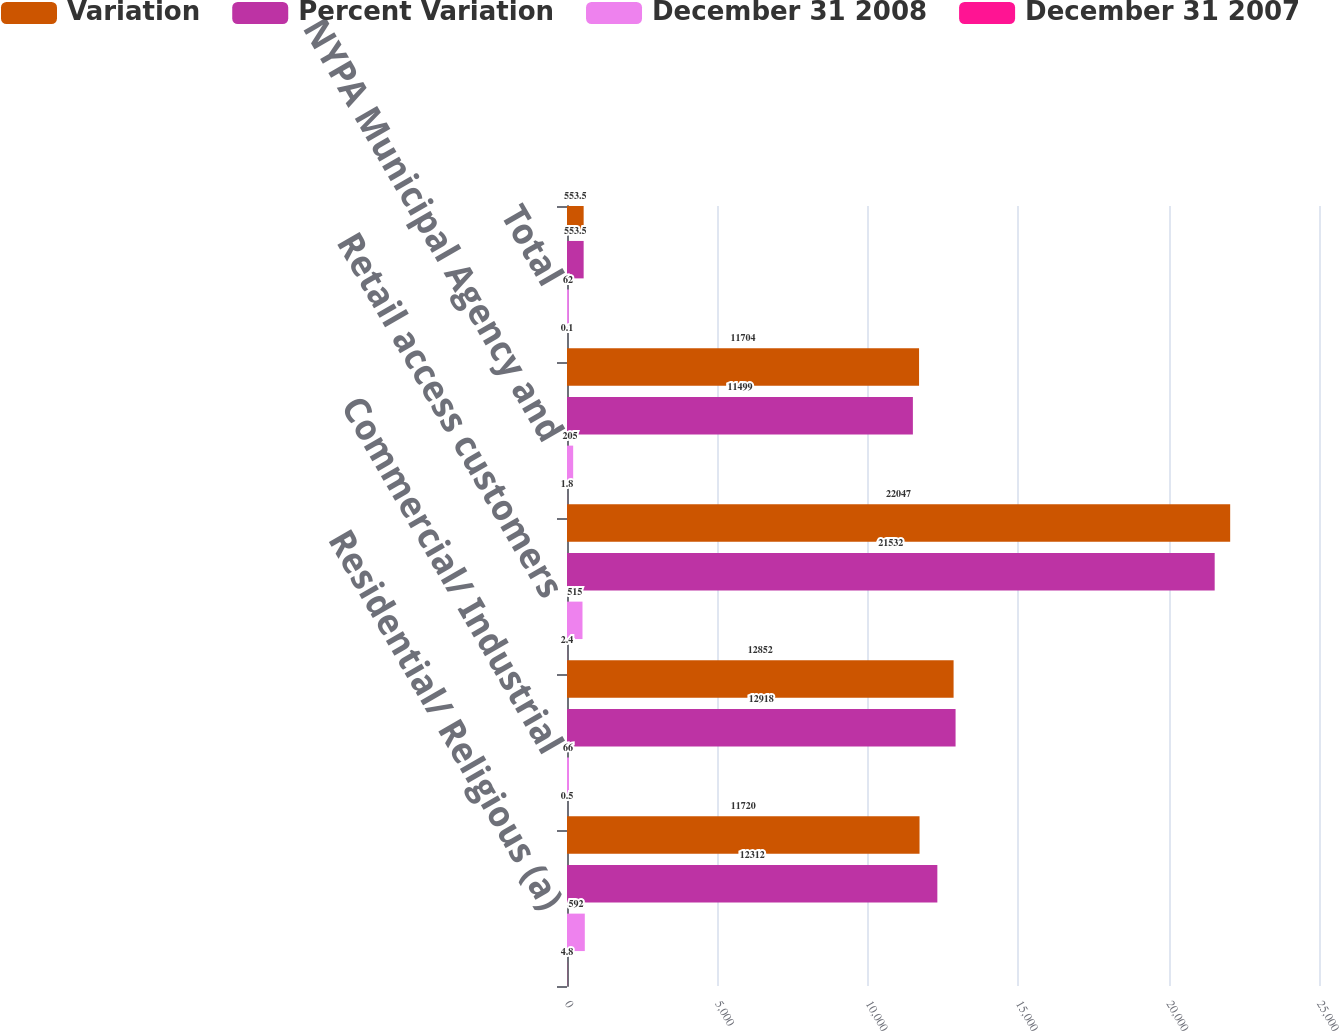Convert chart to OTSL. <chart><loc_0><loc_0><loc_500><loc_500><stacked_bar_chart><ecel><fcel>Residential/ Religious (a)<fcel>Commercial/ Industrial<fcel>Retail access customers<fcel>NYPA Municipal Agency and<fcel>Total<nl><fcel>Variation<fcel>11720<fcel>12852<fcel>22047<fcel>11704<fcel>553.5<nl><fcel>Percent Variation<fcel>12312<fcel>12918<fcel>21532<fcel>11499<fcel>553.5<nl><fcel>December 31 2008<fcel>592<fcel>66<fcel>515<fcel>205<fcel>62<nl><fcel>December 31 2007<fcel>4.8<fcel>0.5<fcel>2.4<fcel>1.8<fcel>0.1<nl></chart> 